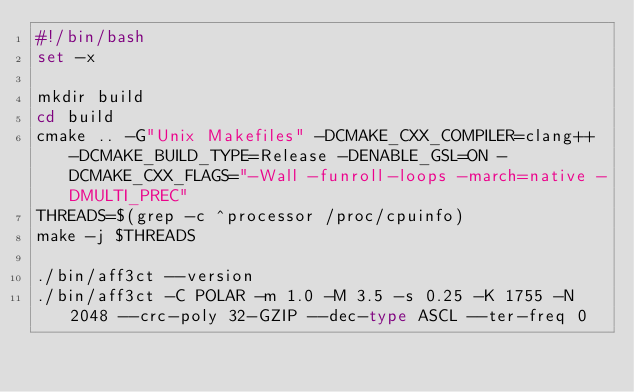Convert code to text. <code><loc_0><loc_0><loc_500><loc_500><_Bash_>#!/bin/bash
set -x

mkdir build
cd build
cmake .. -G"Unix Makefiles" -DCMAKE_CXX_COMPILER=clang++ -DCMAKE_BUILD_TYPE=Release -DENABLE_GSL=ON -DCMAKE_CXX_FLAGS="-Wall -funroll-loops -march=native -DMULTI_PREC"
THREADS=$(grep -c ^processor /proc/cpuinfo)
make -j $THREADS

./bin/aff3ct --version
./bin/aff3ct -C POLAR -m 1.0 -M 3.5 -s 0.25 -K 1755 -N 2048 --crc-poly 32-GZIP --dec-type ASCL --ter-freq 0</code> 